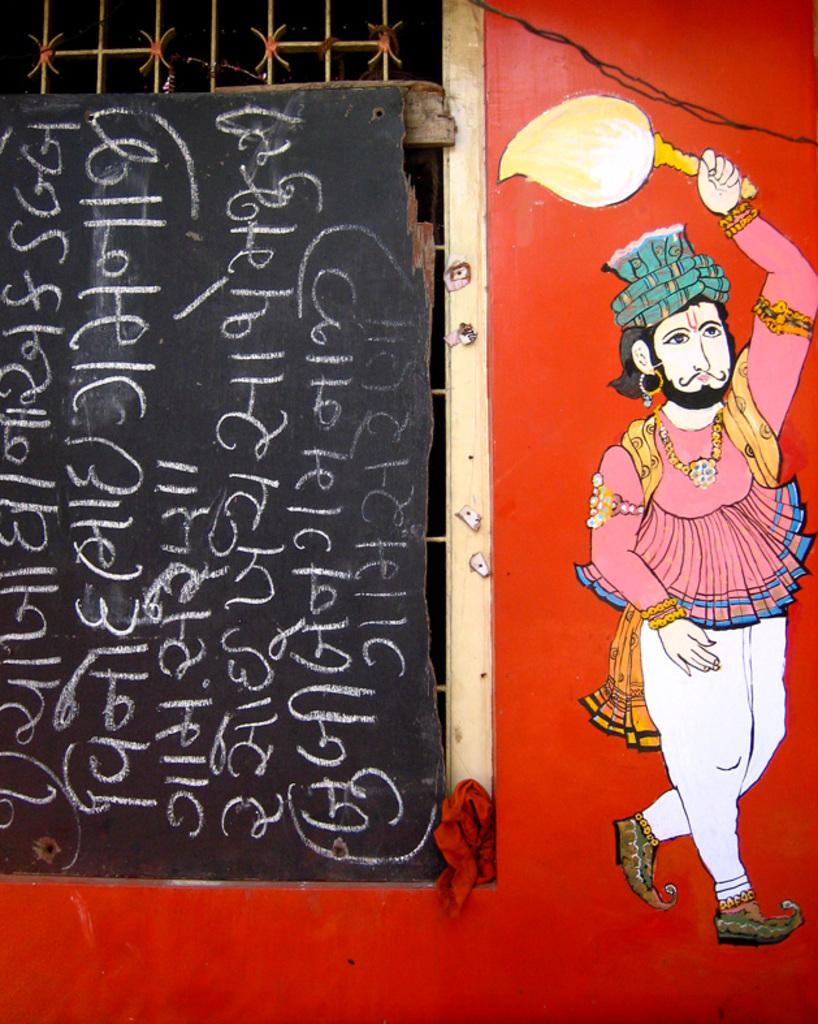What can be seen on the wall in the image? There is a wall in the image, and it has a window and a picture of a person painted on it. What is covering the window in the image? The window is covered with a board in the image. Is there any text on the board covering the window? Yes, the board has text on it. What is the person in the picture holding in his hand? The person in the picture is holding an object in his hand. How many icicles are hanging from the wall in the image? There are no icicles hanging from the wall in the image. What type of stone is used to create the wall in the image? The image does not provide information about the type of stone used to create the wall. --- Facts: 1. There is a person sitting on a chair in the image. 2. The person is holding a book. 3. The book has a title on the cover. 4. The chair is made of wood. 5. The person is wearing glasses. Absurd Topics: parrot, ocean, bicycle Conversation: What is the person in the image doing? The person in the image is sitting on a chair. What is the person holding in the image? The person is holding a book in the image. What can be seen on the cover of the book? The book has a title on the cover. What material is the chair made of? The chair is made of wood. What accessory is the person wearing in the image? The person is wearing glasses in the image. Reasoning: Let's think step by step in order to produce the conversation. We start by identifying the main subject in the image, which is the person sitting on a chair. Then, we expand the conversation to include other details about the person, such as the book they are holding, the title on the book's cover, the material of the chair, and the glasses they are wearing. Each question is designed to elicit a specific detail about the image that is known from the provided facts. Absurd Question/Answer: Can you see a parrot sitting on the person's shoulder in the image? No, there is no parrot present in the image. What type of ocean can be seen in the background of the image? There is no ocean visible in the image. 